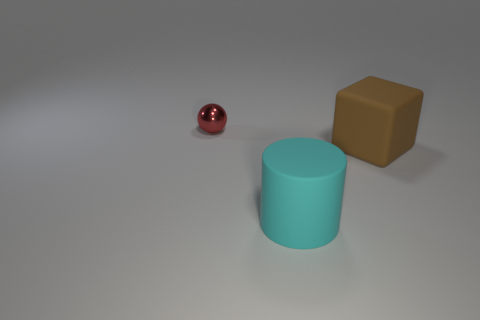There is a object that is both behind the large cyan matte thing and to the left of the brown cube; how big is it?
Your answer should be very brief. Small. What number of red objects are large cubes or small metallic spheres?
Ensure brevity in your answer.  1. What is the shape of the big brown object?
Provide a succinct answer. Cube. What number of other objects are there of the same shape as the small red metallic thing?
Keep it short and to the point. 0. There is a large object behind the cyan object; what is its color?
Give a very brief answer. Brown. Do the big block and the cyan cylinder have the same material?
Give a very brief answer. Yes. How many things are either tiny things or big rubber things to the left of the cube?
Ensure brevity in your answer.  2. What shape is the large object that is on the right side of the cyan matte cylinder?
Offer a very short reply. Cube. There is a large matte object on the left side of the large brown cube; does it have the same color as the ball?
Ensure brevity in your answer.  No. Do the matte thing to the left of the block and the tiny red thing have the same size?
Your answer should be compact. No. 